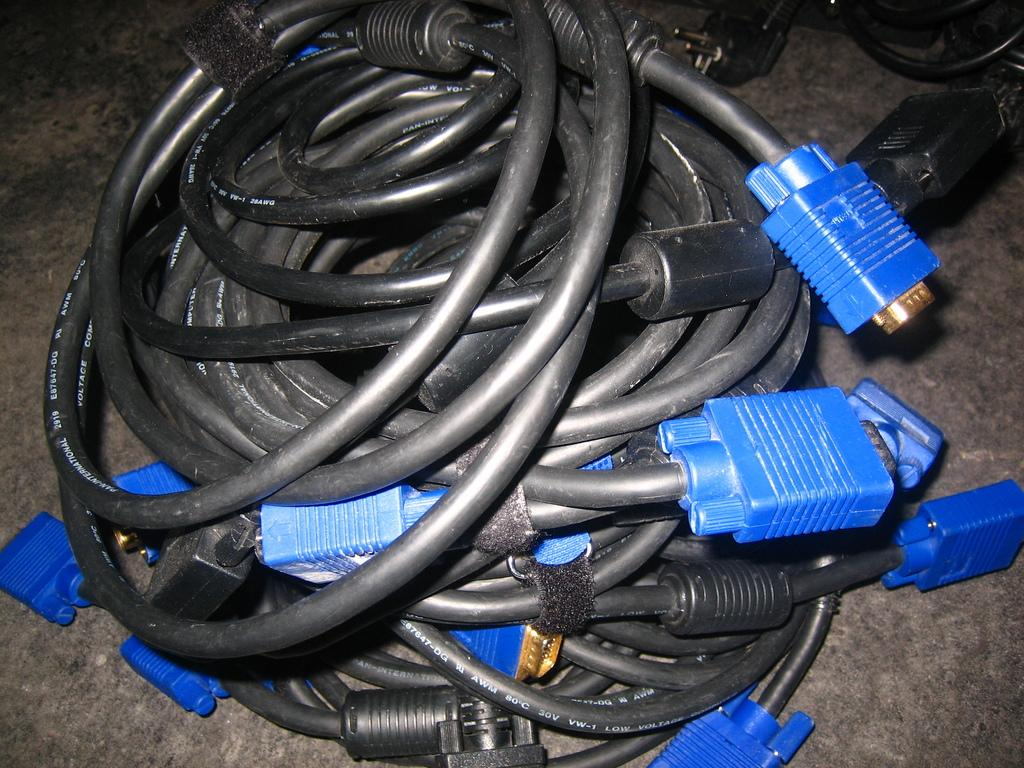What is present in the image that is used for transmitting signals or power? There are wires in the image that are used for transmitting signals or power. What is the color of the wires in the image? The wires in the image are black in color. What type of living organisms can be seen in the image? There are plants in the image. What is the color of the plants in the image? The plants in the image are blue in color. What type of company is mentioned in the image? There is no company mentioned in the image. What kind of ticket can be seen in the image? There is no ticket present in the image. 